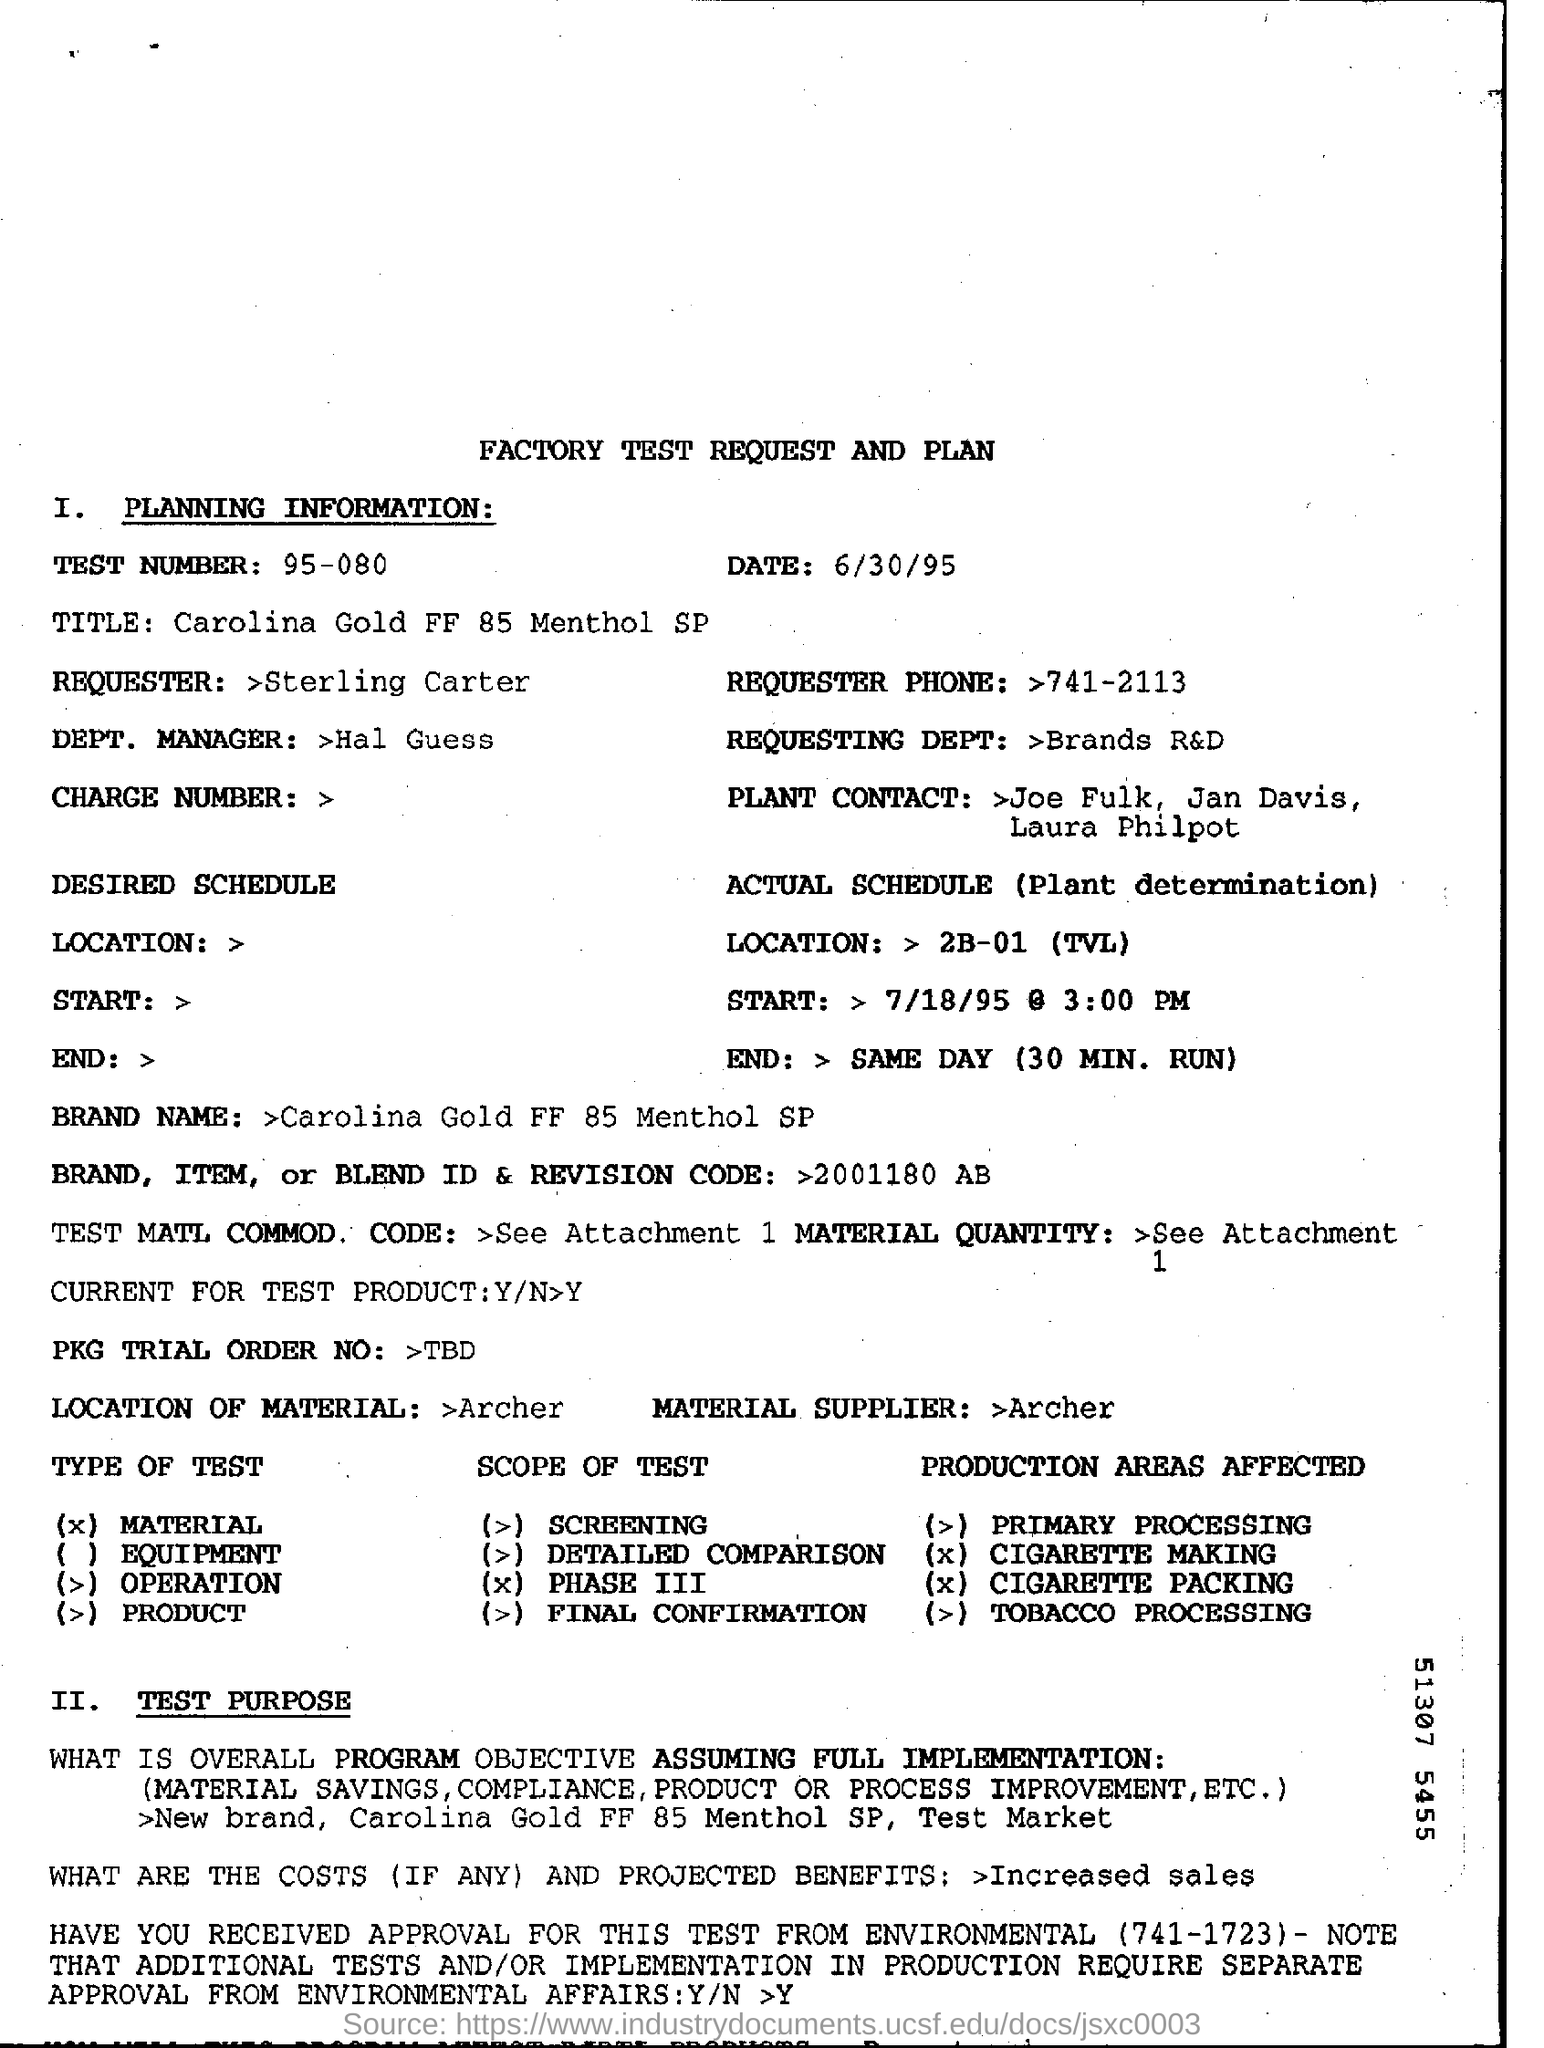Point out several critical features in this image. The test number mentioned in the document is 95-080. The test number is 95-080. The brand name is Carolina Gold FF 85 Menthol SP. 